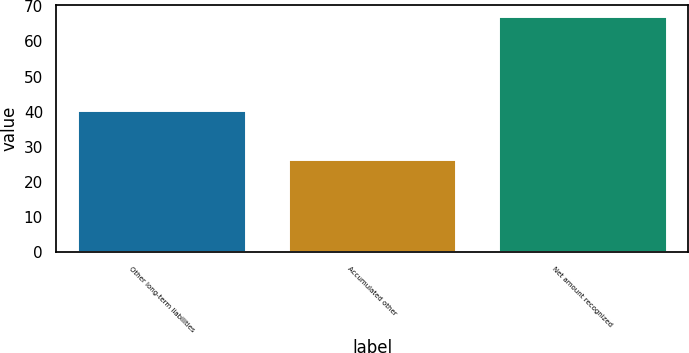Convert chart. <chart><loc_0><loc_0><loc_500><loc_500><bar_chart><fcel>Other long-term liabilities<fcel>Accumulated other<fcel>Net amount recognized<nl><fcel>40.5<fcel>26.6<fcel>67.1<nl></chart> 